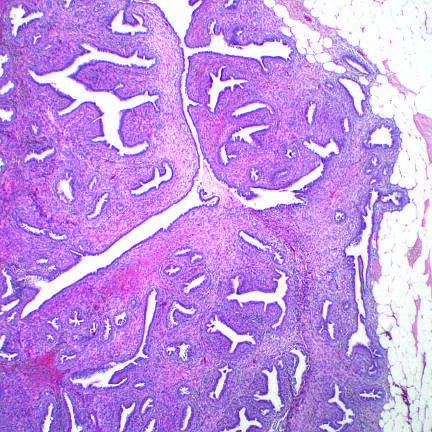what distorts the glandular tissue, forming cleftlike spaces, and bulges into surrounding stroma?
Answer the question using a single word or phrase. Proliferating stromal cells 